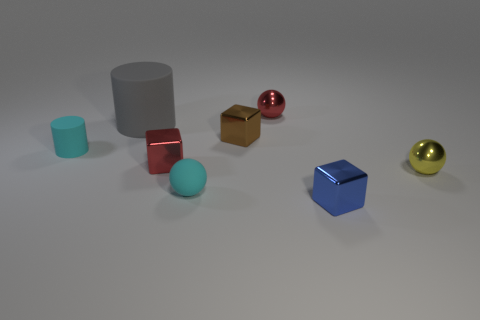Subtract 1 balls. How many balls are left? 2 Subtract all spheres. How many objects are left? 5 Subtract all large yellow objects. Subtract all blue metallic things. How many objects are left? 7 Add 2 tiny brown shiny blocks. How many tiny brown shiny blocks are left? 3 Add 8 big gray rubber objects. How many big gray rubber objects exist? 9 Subtract 1 red cubes. How many objects are left? 7 